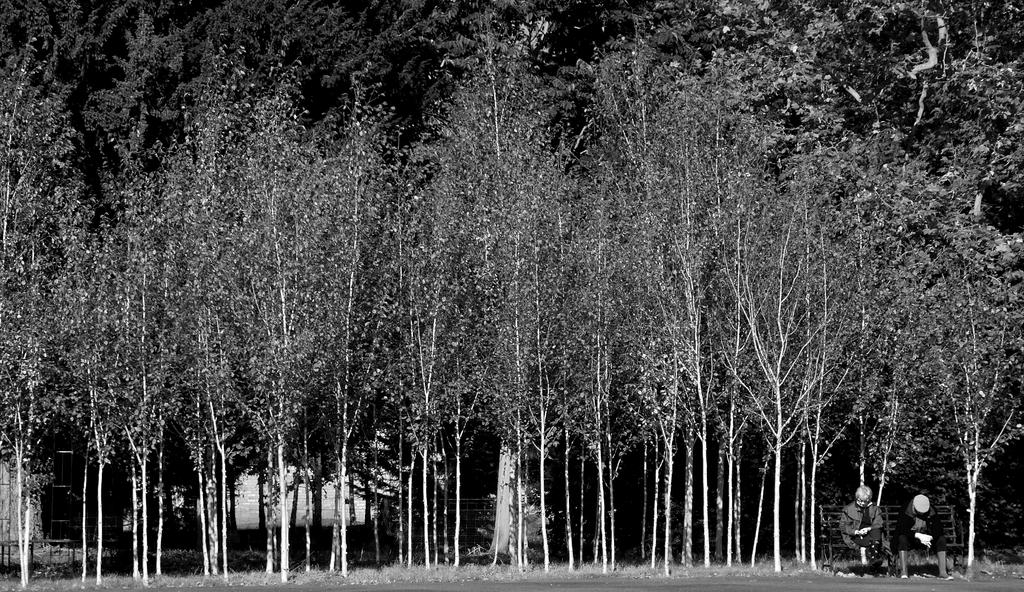How many people are in the image? There are two people in the image. What are the people doing in the image? The people are sitting on a bench. What can be seen in the background of the image? There are trees visible in the image. What type of throat apparatus can be seen in the image? There is no throat apparatus present in the image. What store is visible in the background of the image? There is no store visible in the image; only trees are mentioned in the background. 